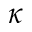Convert formula to latex. <formula><loc_0><loc_0><loc_500><loc_500>\kappa</formula> 